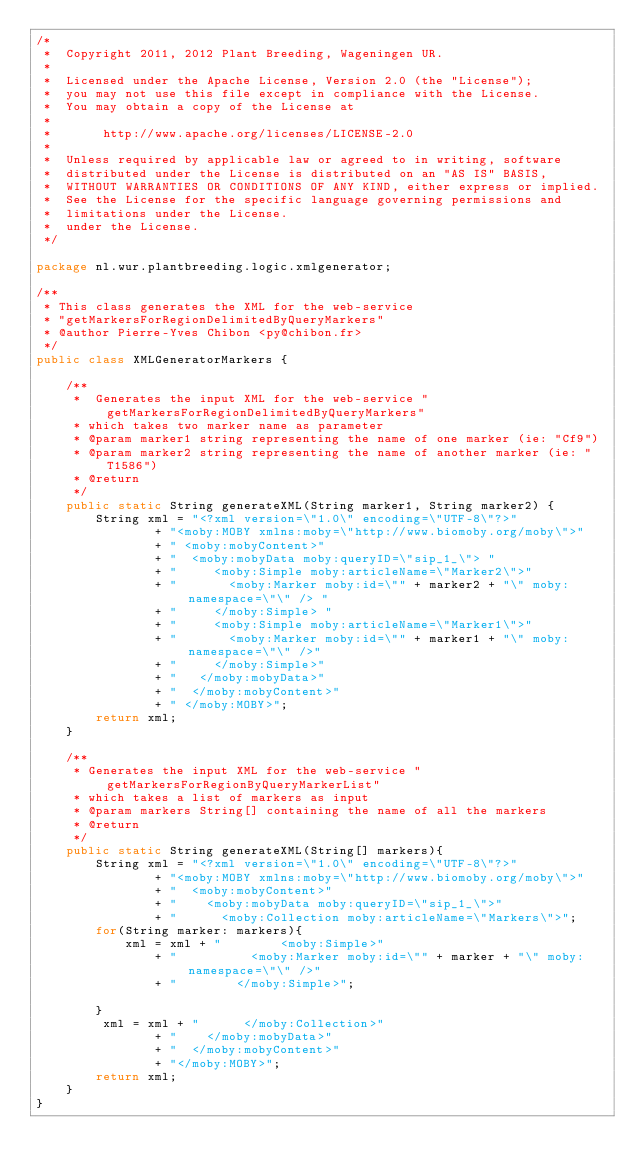<code> <loc_0><loc_0><loc_500><loc_500><_Java_>/*
 *  Copyright 2011, 2012 Plant Breeding, Wageningen UR.
 *
 *  Licensed under the Apache License, Version 2.0 (the "License");
 *  you may not use this file except in compliance with the License.
 *  You may obtain a copy of the License at
 *
 *       http://www.apache.org/licenses/LICENSE-2.0
 *
 *  Unless required by applicable law or agreed to in writing, software
 *  distributed under the License is distributed on an "AS IS" BASIS,
 *  WITHOUT WARRANTIES OR CONDITIONS OF ANY KIND, either express or implied.
 *  See the License for the specific language governing permissions and
 *  limitations under the License.
 *  under the License.
 */

package nl.wur.plantbreeding.logic.xmlgenerator;

/**
 * This class generates the XML for the web-service
 * "getMarkersForRegionDelimitedByQueryMarkers"
 * @author Pierre-Yves Chibon <py@chibon.fr>
 */
public class XMLGeneratorMarkers {

    /**
     *  Generates the input XML for the web-service "getMarkersForRegionDelimitedByQueryMarkers"
     * which takes two marker name as parameter
     * @param marker1 string representing the name of one marker (ie: "Cf9")
     * @param marker2 string representing the name of another marker (ie: "T1586")
     * @return
     */
    public static String generateXML(String marker1, String marker2) {
        String xml = "<?xml version=\"1.0\" encoding=\"UTF-8\"?>"
                + "<moby:MOBY xmlns:moby=\"http://www.biomoby.org/moby\">"
                + " <moby:mobyContent>"
                + "  <moby:mobyData moby:queryID=\"sip_1_\"> "
                + "     <moby:Simple moby:articleName=\"Marker2\">"
                + "       <moby:Marker moby:id=\"" + marker2 + "\" moby:namespace=\"\" /> "
                + "     </moby:Simple> "
                + "     <moby:Simple moby:articleName=\"Marker1\">"
                + "       <moby:Marker moby:id=\"" + marker1 + "\" moby:namespace=\"\" />"
                + "     </moby:Simple>"
                + "   </moby:mobyData>"
                + "  </moby:mobyContent>"
                + " </moby:MOBY>";
        return xml;
    }

    /**
     * Generates the input XML for the web-service "getMarkersForRegionByQueryMarkerList"
     * which takes a list of markers as input
     * @param markers String[] containing the name of all the markers
     * @return
     */
    public static String generateXML(String[] markers){
        String xml = "<?xml version=\"1.0\" encoding=\"UTF-8\"?>"
                + "<moby:MOBY xmlns:moby=\"http://www.biomoby.org/moby\">"
                + "  <moby:mobyContent>"
                + "    <moby:mobyData moby:queryID=\"sip_1_\">"
                + "      <moby:Collection moby:articleName=\"Markers\">";
        for(String marker: markers){
            xml = xml + "        <moby:Simple>"
                + "          <moby:Marker moby:id=\"" + marker + "\" moby:namespace=\"\" />"
                + "        </moby:Simple>";

        }
         xml = xml + "      </moby:Collection>"
                + "    </moby:mobyData>"
                + "  </moby:mobyContent>"
                + "</moby:MOBY>";
        return xml;
    }
}
</code> 